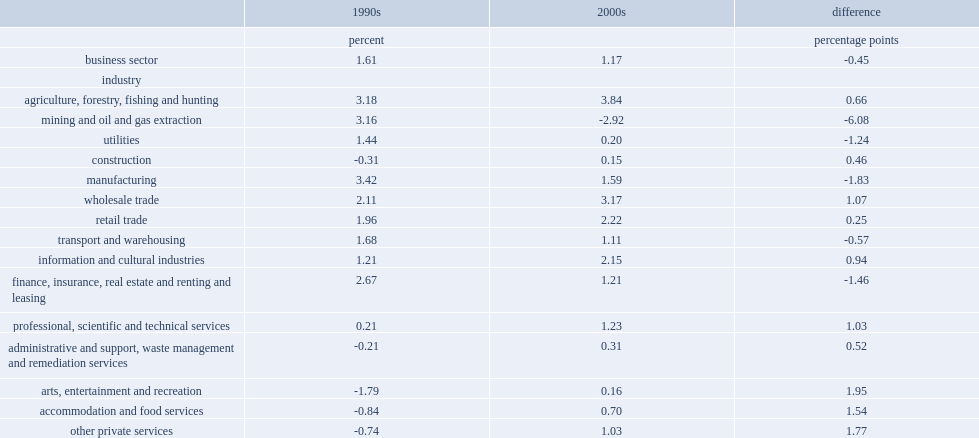What percent of labour productivity in the 2000s for the mining, oil and gas sector has declined? 2.92. Which industry had the largest deceleration in labour productivity from the average annual growth rate recorded in the 1990s? Mining and oil and gas extraction. What is the labour productivity growth in mining, oil and gas in the 1990s? 3.16. What percent of the finance, insurance and real estate sector's labor productivity growth has changed? 1.46. 